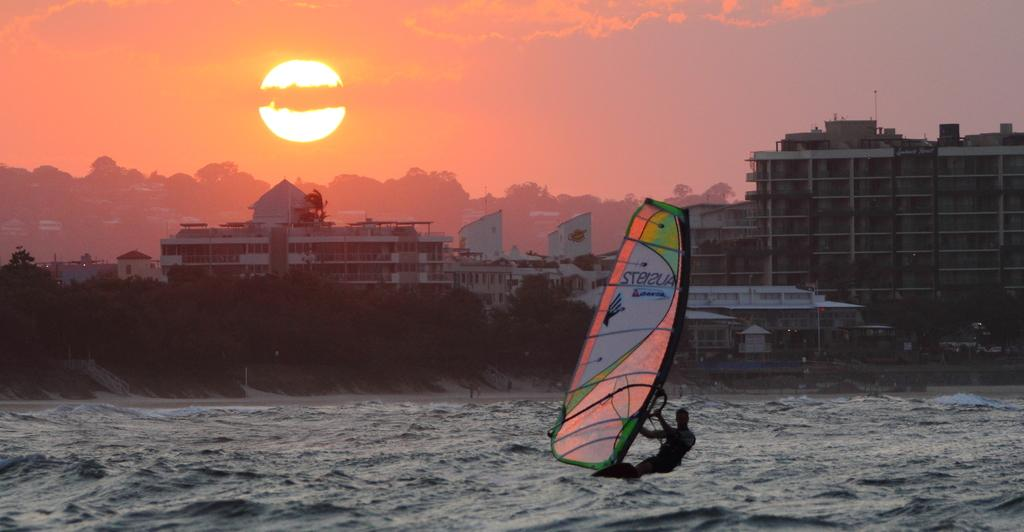What activity is the person in the image engaged in? The person is windsurfing in the image. What can be seen in the background of the image? The sky, clouds, the sun, buildings, trees, and water are visible in the background of the image. What type of office can be seen in the image? There is no office present in the image; it features a person windsurfing in a water setting. What emotion does the person in the image appear to be experiencing? The image does not convey any specific emotion, as it only shows a person windsurfing. 